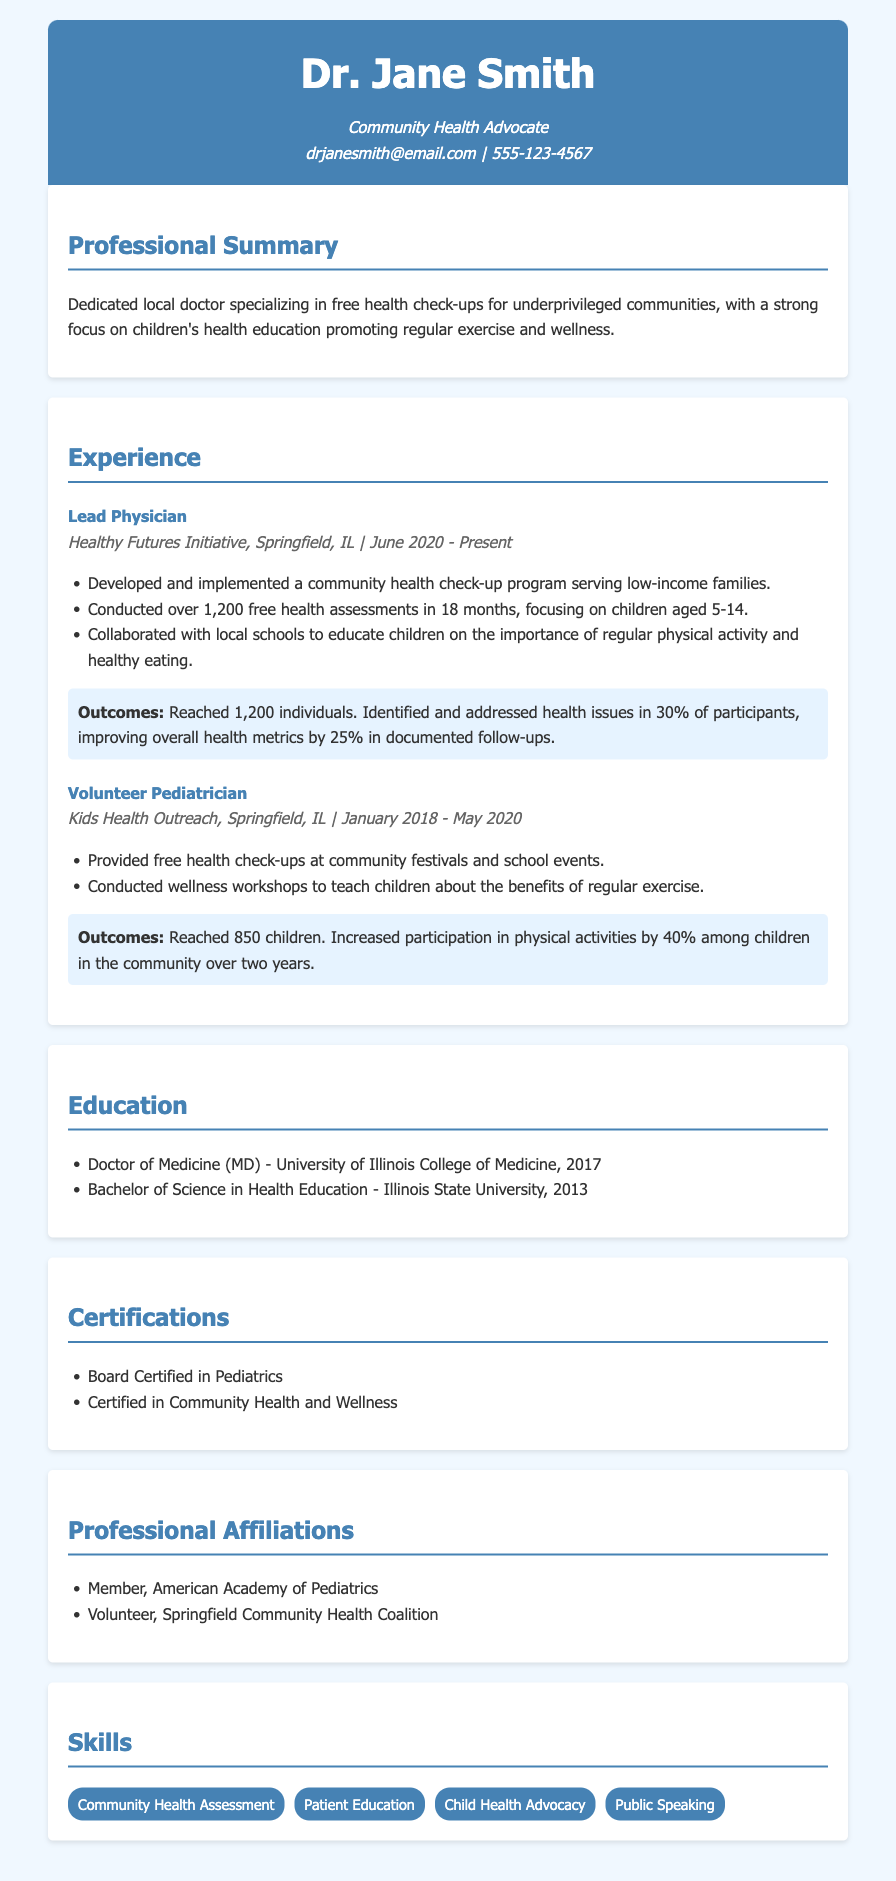what position does Dr. Jane Smith currently hold? The document states her current position as Lead Physician at Healthy Futures Initiative.
Answer: Lead Physician how many health assessments did Dr. Jane Smith conduct in 18 months? The document indicates she conducted over 1,200 health assessments during that time.
Answer: over 1,200 what percentage of participants had health issues identified? The CV mentions that 30% of participants had health issues identified.
Answer: 30% what was the increased participation in physical activities among children during her volunteering? The document states that there was a 40% increase in participation in physical activities.
Answer: 40% which institution awarded Dr. Jane Smith her medical degree? The curriculum vitae lists the University of Illinois College of Medicine as the institution.
Answer: University of Illinois College of Medicine what years did Dr. Jane Smith volunteer as a Pediatrician? The document specifies she volunteered from January 2018 to May 2020.
Answer: January 2018 - May 2020 what is the focus area of Dr. Jane Smith’s health check-up program? The CV mentions the focus is on low-income families.
Answer: low-income families how many children did Dr. Jane Smith reach during her volunteering? According to the document, she reached 850 children during her volunteering.
Answer: 850 children what type of health initiatives does Dr. Jane Smith specialize in? The curriculum vitae highlights her specialization in free health check-ups for underprivileged communities.
Answer: free health check-ups 